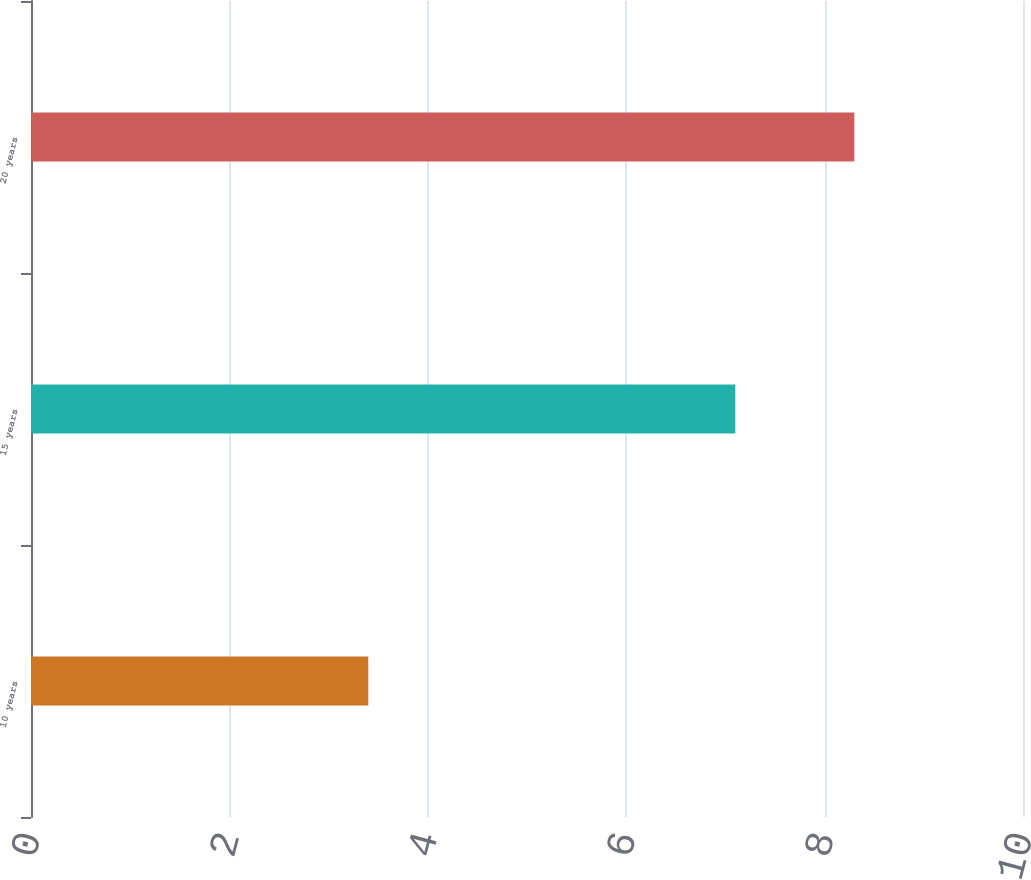Convert chart. <chart><loc_0><loc_0><loc_500><loc_500><bar_chart><fcel>10 years<fcel>15 years<fcel>20 years<nl><fcel>3.4<fcel>7.1<fcel>8.3<nl></chart> 